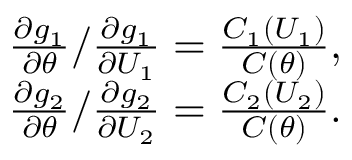<formula> <loc_0><loc_0><loc_500><loc_500>\begin{array} { r } { \frac { \partial g _ { 1 } } { \partial \theta } / \frac { \partial g _ { 1 } } { \partial U _ { 1 } } = \frac { C _ { 1 } ( U _ { 1 } ) } { C ( \theta ) } , } \\ { \frac { \partial g _ { 2 } } { \partial \theta } / \frac { \partial g _ { 2 } } { \partial U _ { 2 } } = \frac { C _ { 2 } ( U _ { 2 } ) } { C ( \theta ) } . } \end{array}</formula> 